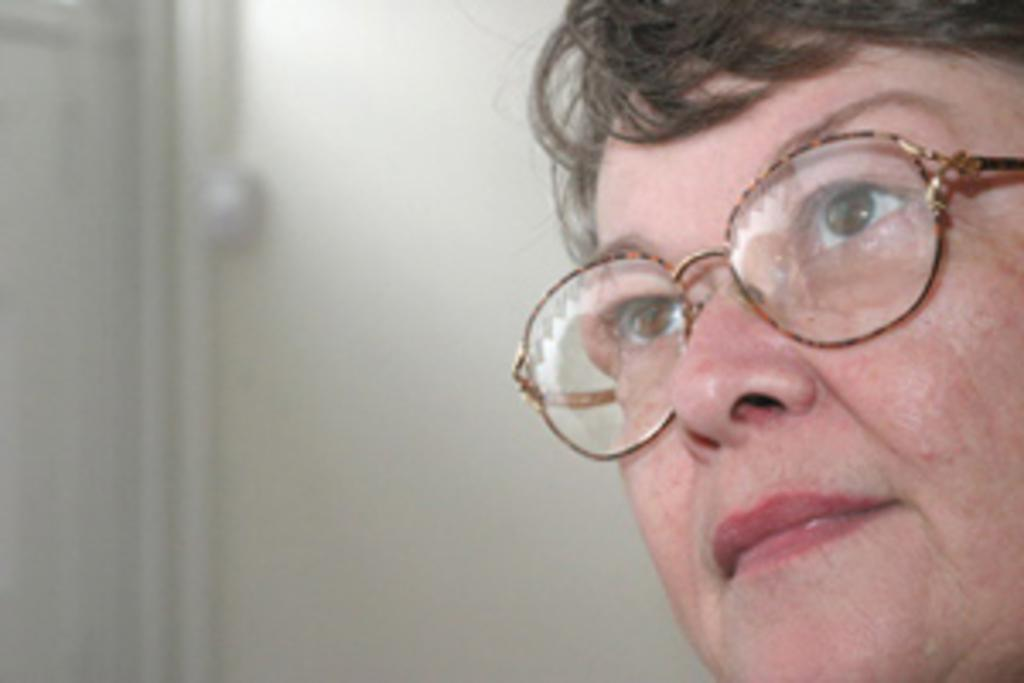What is the main subject of the image? The main subject of the image is a person's face. What accessory is the person wearing in the image? The person is wearing glasses (specs) in the image. What color is the background of the image? The background of the image is white. How many tomatoes can be seen on the person's face in the image? There are no tomatoes present on the person's face in the image. What type of lizard is crawling on the person's glasses in the image? There are no lizards present in the image; the person is wearing glasses (specs). 